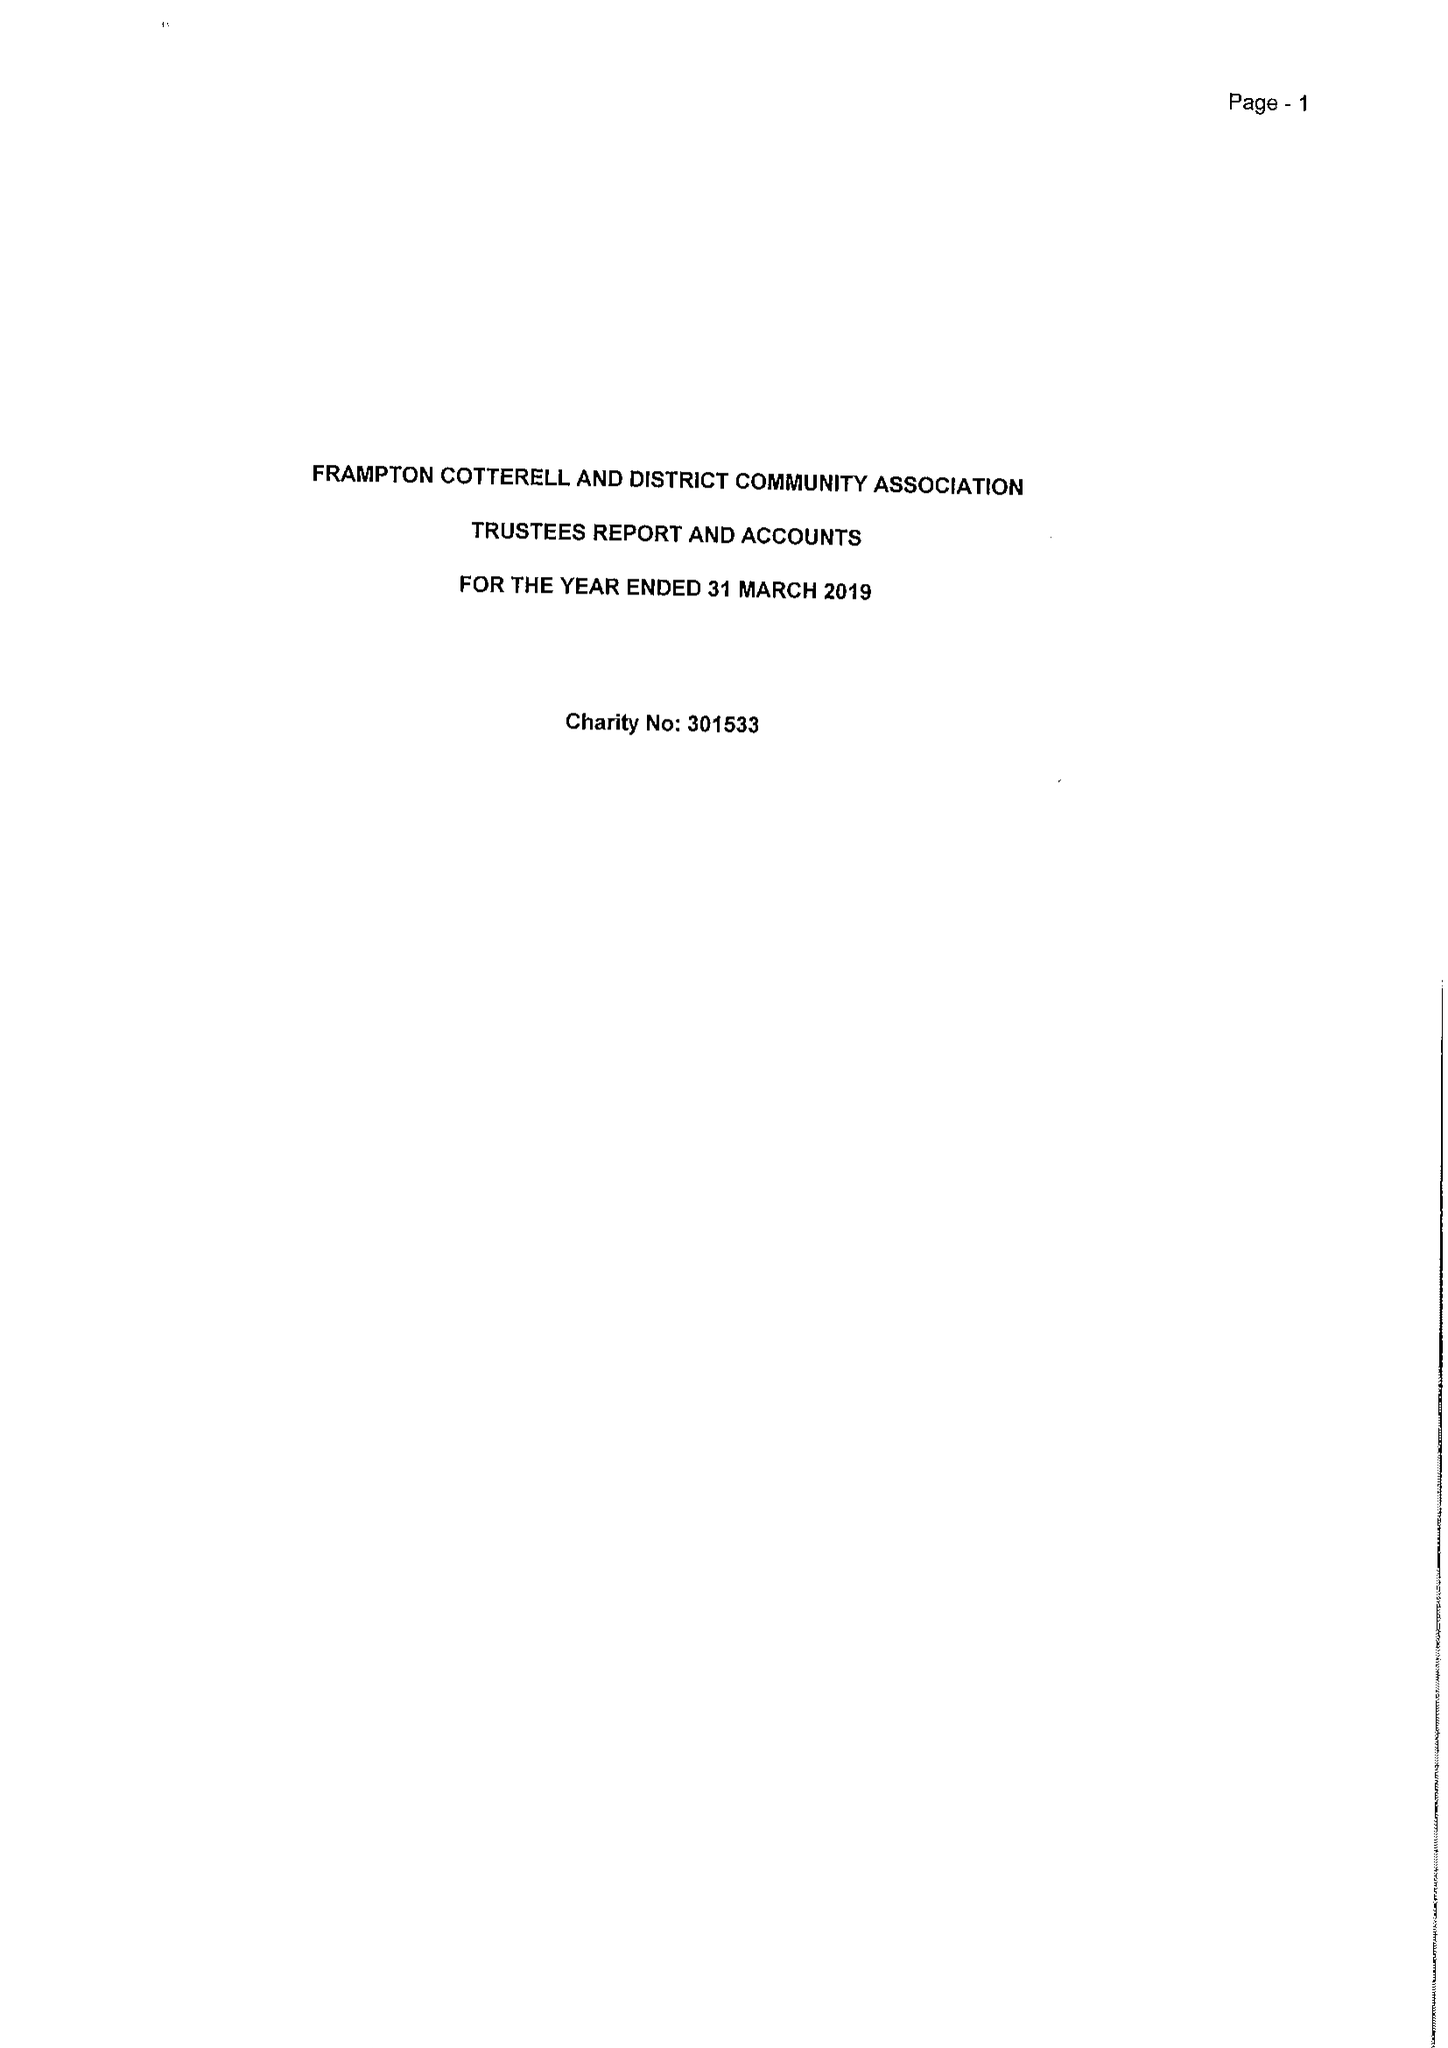What is the value for the charity_number?
Answer the question using a single word or phrase. 301533 